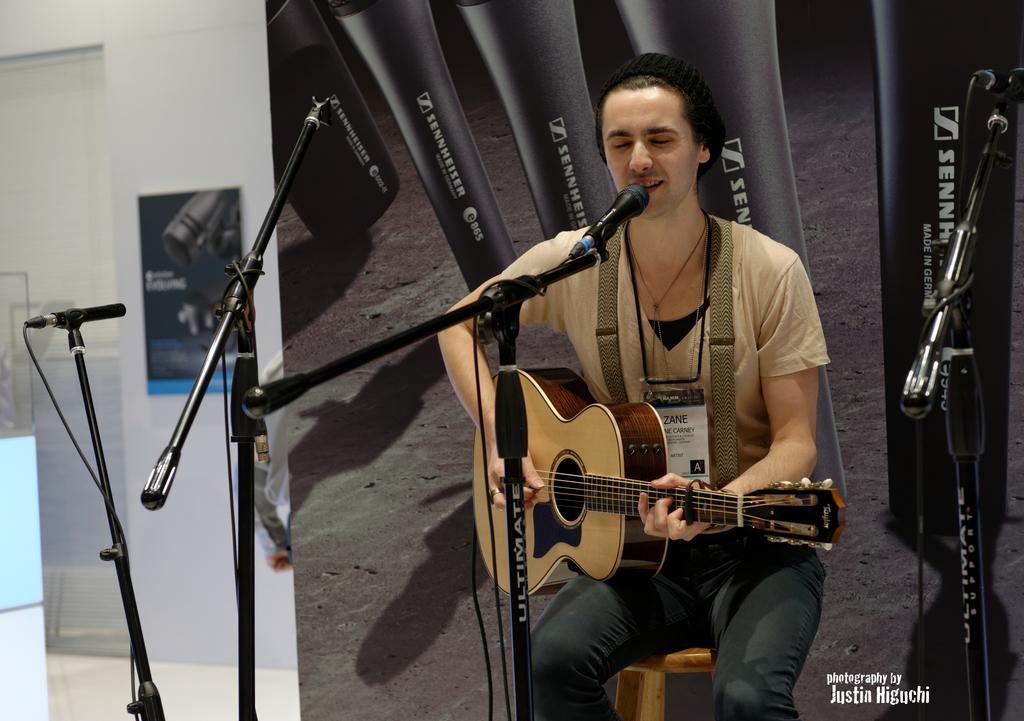How would you summarize this image in a sentence or two? This man is sitting on the stool, playing guitar and singing. This is a mic. This is the stand. In the background, there is a image. This is the wall. And this is the floor. 